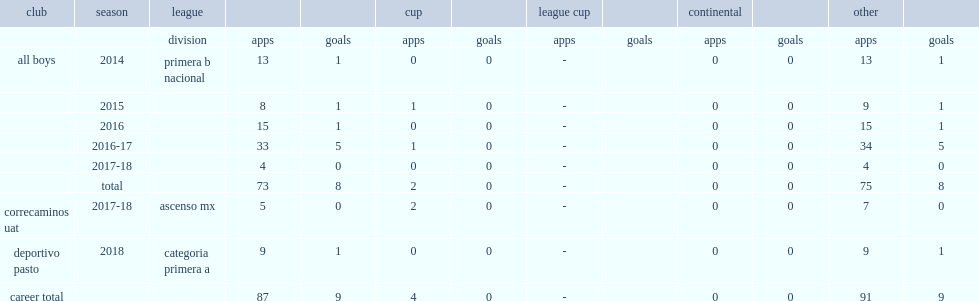Which league did in a copa argentina vazquez make his appearance for all boys? Primera b nacional. 